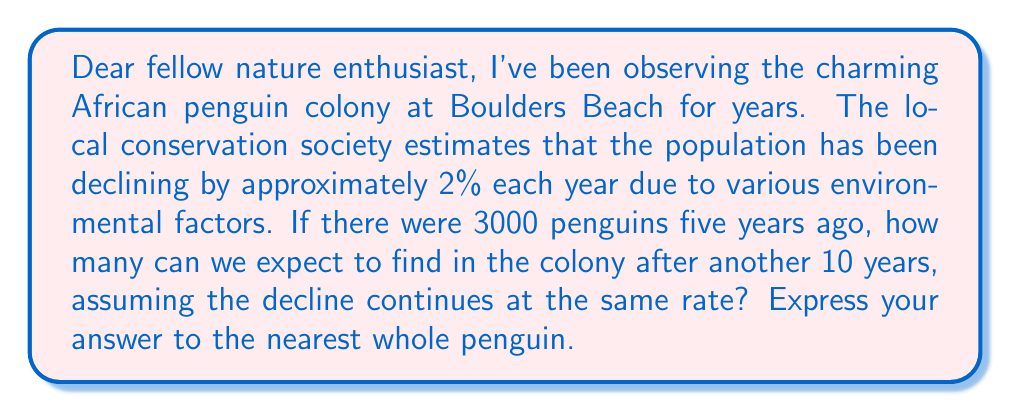Show me your answer to this math problem. To solve this problem, we'll use an exponential series to model the declining population:

1) Let's define our variables:
   $P_0 = 3000$ (initial population 5 years ago)
   $r = -0.02$ (rate of decline per year)
   $t = 15$ (total years: 5 past + 10 future)

2) The formula for exponential growth/decline is:
   $P(t) = P_0 \cdot (1+r)^t$

3) Substituting our values:
   $P(15) = 3000 \cdot (1-0.02)^{15}$

4) Let's calculate step by step:
   $P(15) = 3000 \cdot (0.98)^{15}$
   $= 3000 \cdot 0.7396$ (using a calculator)
   $= 2218.8$

5) Rounding to the nearest whole penguin:
   $2219$ penguins

Thus, after 15 years (5 years ago to now, plus 10 years into the future), we can expect approximately 2219 penguins in the colony.
Answer: 2219 penguins 